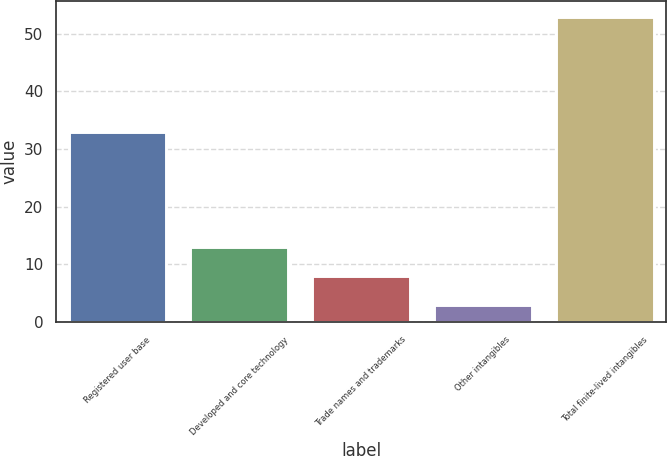<chart> <loc_0><loc_0><loc_500><loc_500><bar_chart><fcel>Registered user base<fcel>Developed and core technology<fcel>Trade names and trademarks<fcel>Other intangibles<fcel>Total finite-lived intangibles<nl><fcel>33<fcel>13<fcel>8<fcel>3<fcel>53<nl></chart> 